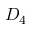Convert formula to latex. <formula><loc_0><loc_0><loc_500><loc_500>D _ { 4 }</formula> 